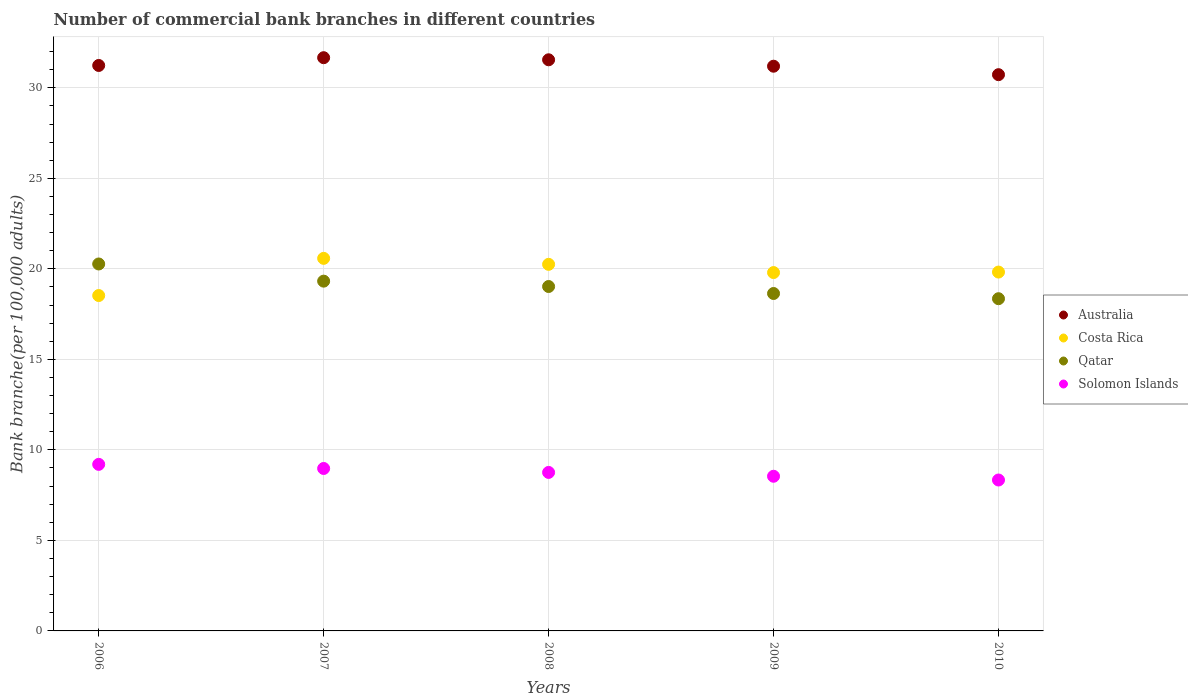Is the number of dotlines equal to the number of legend labels?
Provide a short and direct response. Yes. What is the number of commercial bank branches in Qatar in 2007?
Ensure brevity in your answer.  19.32. Across all years, what is the maximum number of commercial bank branches in Costa Rica?
Give a very brief answer. 20.58. Across all years, what is the minimum number of commercial bank branches in Solomon Islands?
Provide a succinct answer. 8.34. In which year was the number of commercial bank branches in Costa Rica minimum?
Keep it short and to the point. 2006. What is the total number of commercial bank branches in Costa Rica in the graph?
Offer a very short reply. 98.97. What is the difference between the number of commercial bank branches in Solomon Islands in 2006 and that in 2007?
Offer a terse response. 0.23. What is the difference between the number of commercial bank branches in Solomon Islands in 2009 and the number of commercial bank branches in Qatar in 2008?
Give a very brief answer. -10.48. What is the average number of commercial bank branches in Qatar per year?
Give a very brief answer. 19.12. In the year 2008, what is the difference between the number of commercial bank branches in Solomon Islands and number of commercial bank branches in Costa Rica?
Your answer should be compact. -11.49. What is the ratio of the number of commercial bank branches in Costa Rica in 2007 to that in 2009?
Your response must be concise. 1.04. Is the difference between the number of commercial bank branches in Solomon Islands in 2009 and 2010 greater than the difference between the number of commercial bank branches in Costa Rica in 2009 and 2010?
Your response must be concise. Yes. What is the difference between the highest and the second highest number of commercial bank branches in Costa Rica?
Provide a succinct answer. 0.33. What is the difference between the highest and the lowest number of commercial bank branches in Costa Rica?
Offer a terse response. 2.05. Is it the case that in every year, the sum of the number of commercial bank branches in Solomon Islands and number of commercial bank branches in Australia  is greater than the sum of number of commercial bank branches in Costa Rica and number of commercial bank branches in Qatar?
Make the answer very short. No. Is it the case that in every year, the sum of the number of commercial bank branches in Costa Rica and number of commercial bank branches in Qatar  is greater than the number of commercial bank branches in Australia?
Your response must be concise. Yes. Does the number of commercial bank branches in Australia monotonically increase over the years?
Your response must be concise. No. How many years are there in the graph?
Provide a short and direct response. 5. What is the difference between two consecutive major ticks on the Y-axis?
Provide a succinct answer. 5. Are the values on the major ticks of Y-axis written in scientific E-notation?
Your response must be concise. No. How are the legend labels stacked?
Keep it short and to the point. Vertical. What is the title of the graph?
Offer a terse response. Number of commercial bank branches in different countries. What is the label or title of the X-axis?
Your response must be concise. Years. What is the label or title of the Y-axis?
Ensure brevity in your answer.  Bank branche(per 100,0 adults). What is the Bank branche(per 100,000 adults) in Australia in 2006?
Keep it short and to the point. 31.23. What is the Bank branche(per 100,000 adults) in Costa Rica in 2006?
Your response must be concise. 18.53. What is the Bank branche(per 100,000 adults) in Qatar in 2006?
Provide a short and direct response. 20.27. What is the Bank branche(per 100,000 adults) of Solomon Islands in 2006?
Offer a very short reply. 9.2. What is the Bank branche(per 100,000 adults) of Australia in 2007?
Your answer should be compact. 31.66. What is the Bank branche(per 100,000 adults) of Costa Rica in 2007?
Your answer should be very brief. 20.58. What is the Bank branche(per 100,000 adults) of Qatar in 2007?
Provide a succinct answer. 19.32. What is the Bank branche(per 100,000 adults) in Solomon Islands in 2007?
Your response must be concise. 8.97. What is the Bank branche(per 100,000 adults) of Australia in 2008?
Your answer should be very brief. 31.55. What is the Bank branche(per 100,000 adults) in Costa Rica in 2008?
Offer a very short reply. 20.25. What is the Bank branche(per 100,000 adults) in Qatar in 2008?
Offer a terse response. 19.02. What is the Bank branche(per 100,000 adults) in Solomon Islands in 2008?
Provide a succinct answer. 8.75. What is the Bank branche(per 100,000 adults) of Australia in 2009?
Offer a terse response. 31.19. What is the Bank branche(per 100,000 adults) of Costa Rica in 2009?
Provide a short and direct response. 19.79. What is the Bank branche(per 100,000 adults) of Qatar in 2009?
Your answer should be very brief. 18.64. What is the Bank branche(per 100,000 adults) of Solomon Islands in 2009?
Ensure brevity in your answer.  8.54. What is the Bank branche(per 100,000 adults) of Australia in 2010?
Keep it short and to the point. 30.73. What is the Bank branche(per 100,000 adults) in Costa Rica in 2010?
Your response must be concise. 19.82. What is the Bank branche(per 100,000 adults) of Qatar in 2010?
Provide a short and direct response. 18.35. What is the Bank branche(per 100,000 adults) in Solomon Islands in 2010?
Make the answer very short. 8.34. Across all years, what is the maximum Bank branche(per 100,000 adults) of Australia?
Provide a short and direct response. 31.66. Across all years, what is the maximum Bank branche(per 100,000 adults) of Costa Rica?
Give a very brief answer. 20.58. Across all years, what is the maximum Bank branche(per 100,000 adults) of Qatar?
Your response must be concise. 20.27. Across all years, what is the maximum Bank branche(per 100,000 adults) in Solomon Islands?
Your response must be concise. 9.2. Across all years, what is the minimum Bank branche(per 100,000 adults) of Australia?
Your response must be concise. 30.73. Across all years, what is the minimum Bank branche(per 100,000 adults) of Costa Rica?
Provide a short and direct response. 18.53. Across all years, what is the minimum Bank branche(per 100,000 adults) in Qatar?
Your answer should be very brief. 18.35. Across all years, what is the minimum Bank branche(per 100,000 adults) in Solomon Islands?
Provide a short and direct response. 8.34. What is the total Bank branche(per 100,000 adults) of Australia in the graph?
Provide a short and direct response. 156.36. What is the total Bank branche(per 100,000 adults) in Costa Rica in the graph?
Offer a very short reply. 98.97. What is the total Bank branche(per 100,000 adults) in Qatar in the graph?
Provide a short and direct response. 95.6. What is the total Bank branche(per 100,000 adults) of Solomon Islands in the graph?
Your response must be concise. 43.81. What is the difference between the Bank branche(per 100,000 adults) of Australia in 2006 and that in 2007?
Give a very brief answer. -0.43. What is the difference between the Bank branche(per 100,000 adults) of Costa Rica in 2006 and that in 2007?
Give a very brief answer. -2.05. What is the difference between the Bank branche(per 100,000 adults) in Qatar in 2006 and that in 2007?
Your answer should be compact. 0.95. What is the difference between the Bank branche(per 100,000 adults) in Solomon Islands in 2006 and that in 2007?
Your response must be concise. 0.23. What is the difference between the Bank branche(per 100,000 adults) in Australia in 2006 and that in 2008?
Make the answer very short. -0.31. What is the difference between the Bank branche(per 100,000 adults) in Costa Rica in 2006 and that in 2008?
Your answer should be very brief. -1.72. What is the difference between the Bank branche(per 100,000 adults) in Qatar in 2006 and that in 2008?
Provide a short and direct response. 1.25. What is the difference between the Bank branche(per 100,000 adults) of Solomon Islands in 2006 and that in 2008?
Make the answer very short. 0.45. What is the difference between the Bank branche(per 100,000 adults) in Australia in 2006 and that in 2009?
Give a very brief answer. 0.04. What is the difference between the Bank branche(per 100,000 adults) in Costa Rica in 2006 and that in 2009?
Provide a succinct answer. -1.27. What is the difference between the Bank branche(per 100,000 adults) of Qatar in 2006 and that in 2009?
Give a very brief answer. 1.63. What is the difference between the Bank branche(per 100,000 adults) in Solomon Islands in 2006 and that in 2009?
Your answer should be very brief. 0.66. What is the difference between the Bank branche(per 100,000 adults) in Australia in 2006 and that in 2010?
Offer a very short reply. 0.51. What is the difference between the Bank branche(per 100,000 adults) of Costa Rica in 2006 and that in 2010?
Your answer should be compact. -1.3. What is the difference between the Bank branche(per 100,000 adults) of Qatar in 2006 and that in 2010?
Your answer should be compact. 1.92. What is the difference between the Bank branche(per 100,000 adults) of Solomon Islands in 2006 and that in 2010?
Ensure brevity in your answer.  0.86. What is the difference between the Bank branche(per 100,000 adults) in Australia in 2007 and that in 2008?
Keep it short and to the point. 0.12. What is the difference between the Bank branche(per 100,000 adults) in Costa Rica in 2007 and that in 2008?
Provide a short and direct response. 0.33. What is the difference between the Bank branche(per 100,000 adults) of Qatar in 2007 and that in 2008?
Provide a short and direct response. 0.3. What is the difference between the Bank branche(per 100,000 adults) in Solomon Islands in 2007 and that in 2008?
Provide a short and direct response. 0.22. What is the difference between the Bank branche(per 100,000 adults) of Australia in 2007 and that in 2009?
Provide a short and direct response. 0.47. What is the difference between the Bank branche(per 100,000 adults) of Costa Rica in 2007 and that in 2009?
Give a very brief answer. 0.78. What is the difference between the Bank branche(per 100,000 adults) in Qatar in 2007 and that in 2009?
Your answer should be very brief. 0.68. What is the difference between the Bank branche(per 100,000 adults) in Solomon Islands in 2007 and that in 2009?
Ensure brevity in your answer.  0.43. What is the difference between the Bank branche(per 100,000 adults) of Australia in 2007 and that in 2010?
Offer a very short reply. 0.94. What is the difference between the Bank branche(per 100,000 adults) of Costa Rica in 2007 and that in 2010?
Offer a terse response. 0.76. What is the difference between the Bank branche(per 100,000 adults) in Qatar in 2007 and that in 2010?
Your answer should be very brief. 0.97. What is the difference between the Bank branche(per 100,000 adults) of Solomon Islands in 2007 and that in 2010?
Your answer should be very brief. 0.64. What is the difference between the Bank branche(per 100,000 adults) in Australia in 2008 and that in 2009?
Give a very brief answer. 0.35. What is the difference between the Bank branche(per 100,000 adults) of Costa Rica in 2008 and that in 2009?
Keep it short and to the point. 0.45. What is the difference between the Bank branche(per 100,000 adults) in Qatar in 2008 and that in 2009?
Your answer should be very brief. 0.39. What is the difference between the Bank branche(per 100,000 adults) in Solomon Islands in 2008 and that in 2009?
Give a very brief answer. 0.21. What is the difference between the Bank branche(per 100,000 adults) of Australia in 2008 and that in 2010?
Your answer should be very brief. 0.82. What is the difference between the Bank branche(per 100,000 adults) in Costa Rica in 2008 and that in 2010?
Your response must be concise. 0.43. What is the difference between the Bank branche(per 100,000 adults) in Qatar in 2008 and that in 2010?
Provide a short and direct response. 0.67. What is the difference between the Bank branche(per 100,000 adults) in Solomon Islands in 2008 and that in 2010?
Keep it short and to the point. 0.42. What is the difference between the Bank branche(per 100,000 adults) of Australia in 2009 and that in 2010?
Offer a terse response. 0.47. What is the difference between the Bank branche(per 100,000 adults) in Costa Rica in 2009 and that in 2010?
Provide a succinct answer. -0.03. What is the difference between the Bank branche(per 100,000 adults) in Qatar in 2009 and that in 2010?
Your answer should be compact. 0.29. What is the difference between the Bank branche(per 100,000 adults) in Solomon Islands in 2009 and that in 2010?
Provide a succinct answer. 0.21. What is the difference between the Bank branche(per 100,000 adults) of Australia in 2006 and the Bank branche(per 100,000 adults) of Costa Rica in 2007?
Provide a short and direct response. 10.65. What is the difference between the Bank branche(per 100,000 adults) in Australia in 2006 and the Bank branche(per 100,000 adults) in Qatar in 2007?
Give a very brief answer. 11.91. What is the difference between the Bank branche(per 100,000 adults) in Australia in 2006 and the Bank branche(per 100,000 adults) in Solomon Islands in 2007?
Offer a terse response. 22.26. What is the difference between the Bank branche(per 100,000 adults) in Costa Rica in 2006 and the Bank branche(per 100,000 adults) in Qatar in 2007?
Make the answer very short. -0.79. What is the difference between the Bank branche(per 100,000 adults) in Costa Rica in 2006 and the Bank branche(per 100,000 adults) in Solomon Islands in 2007?
Provide a short and direct response. 9.55. What is the difference between the Bank branche(per 100,000 adults) of Qatar in 2006 and the Bank branche(per 100,000 adults) of Solomon Islands in 2007?
Make the answer very short. 11.3. What is the difference between the Bank branche(per 100,000 adults) of Australia in 2006 and the Bank branche(per 100,000 adults) of Costa Rica in 2008?
Provide a succinct answer. 10.99. What is the difference between the Bank branche(per 100,000 adults) in Australia in 2006 and the Bank branche(per 100,000 adults) in Qatar in 2008?
Ensure brevity in your answer.  12.21. What is the difference between the Bank branche(per 100,000 adults) of Australia in 2006 and the Bank branche(per 100,000 adults) of Solomon Islands in 2008?
Provide a succinct answer. 22.48. What is the difference between the Bank branche(per 100,000 adults) of Costa Rica in 2006 and the Bank branche(per 100,000 adults) of Qatar in 2008?
Your response must be concise. -0.5. What is the difference between the Bank branche(per 100,000 adults) of Costa Rica in 2006 and the Bank branche(per 100,000 adults) of Solomon Islands in 2008?
Keep it short and to the point. 9.77. What is the difference between the Bank branche(per 100,000 adults) in Qatar in 2006 and the Bank branche(per 100,000 adults) in Solomon Islands in 2008?
Your response must be concise. 11.51. What is the difference between the Bank branche(per 100,000 adults) in Australia in 2006 and the Bank branche(per 100,000 adults) in Costa Rica in 2009?
Provide a succinct answer. 11.44. What is the difference between the Bank branche(per 100,000 adults) in Australia in 2006 and the Bank branche(per 100,000 adults) in Qatar in 2009?
Your answer should be very brief. 12.6. What is the difference between the Bank branche(per 100,000 adults) in Australia in 2006 and the Bank branche(per 100,000 adults) in Solomon Islands in 2009?
Provide a short and direct response. 22.69. What is the difference between the Bank branche(per 100,000 adults) of Costa Rica in 2006 and the Bank branche(per 100,000 adults) of Qatar in 2009?
Your response must be concise. -0.11. What is the difference between the Bank branche(per 100,000 adults) of Costa Rica in 2006 and the Bank branche(per 100,000 adults) of Solomon Islands in 2009?
Ensure brevity in your answer.  9.98. What is the difference between the Bank branche(per 100,000 adults) of Qatar in 2006 and the Bank branche(per 100,000 adults) of Solomon Islands in 2009?
Provide a short and direct response. 11.73. What is the difference between the Bank branche(per 100,000 adults) of Australia in 2006 and the Bank branche(per 100,000 adults) of Costa Rica in 2010?
Provide a succinct answer. 11.41. What is the difference between the Bank branche(per 100,000 adults) in Australia in 2006 and the Bank branche(per 100,000 adults) in Qatar in 2010?
Provide a short and direct response. 12.88. What is the difference between the Bank branche(per 100,000 adults) in Australia in 2006 and the Bank branche(per 100,000 adults) in Solomon Islands in 2010?
Your answer should be very brief. 22.9. What is the difference between the Bank branche(per 100,000 adults) of Costa Rica in 2006 and the Bank branche(per 100,000 adults) of Qatar in 2010?
Your response must be concise. 0.18. What is the difference between the Bank branche(per 100,000 adults) of Costa Rica in 2006 and the Bank branche(per 100,000 adults) of Solomon Islands in 2010?
Ensure brevity in your answer.  10.19. What is the difference between the Bank branche(per 100,000 adults) of Qatar in 2006 and the Bank branche(per 100,000 adults) of Solomon Islands in 2010?
Your response must be concise. 11.93. What is the difference between the Bank branche(per 100,000 adults) of Australia in 2007 and the Bank branche(per 100,000 adults) of Costa Rica in 2008?
Offer a terse response. 11.41. What is the difference between the Bank branche(per 100,000 adults) of Australia in 2007 and the Bank branche(per 100,000 adults) of Qatar in 2008?
Ensure brevity in your answer.  12.64. What is the difference between the Bank branche(per 100,000 adults) of Australia in 2007 and the Bank branche(per 100,000 adults) of Solomon Islands in 2008?
Your answer should be compact. 22.91. What is the difference between the Bank branche(per 100,000 adults) in Costa Rica in 2007 and the Bank branche(per 100,000 adults) in Qatar in 2008?
Keep it short and to the point. 1.56. What is the difference between the Bank branche(per 100,000 adults) in Costa Rica in 2007 and the Bank branche(per 100,000 adults) in Solomon Islands in 2008?
Your answer should be compact. 11.82. What is the difference between the Bank branche(per 100,000 adults) in Qatar in 2007 and the Bank branche(per 100,000 adults) in Solomon Islands in 2008?
Your response must be concise. 10.57. What is the difference between the Bank branche(per 100,000 adults) in Australia in 2007 and the Bank branche(per 100,000 adults) in Costa Rica in 2009?
Keep it short and to the point. 11.87. What is the difference between the Bank branche(per 100,000 adults) of Australia in 2007 and the Bank branche(per 100,000 adults) of Qatar in 2009?
Offer a very short reply. 13.03. What is the difference between the Bank branche(per 100,000 adults) of Australia in 2007 and the Bank branche(per 100,000 adults) of Solomon Islands in 2009?
Ensure brevity in your answer.  23.12. What is the difference between the Bank branche(per 100,000 adults) of Costa Rica in 2007 and the Bank branche(per 100,000 adults) of Qatar in 2009?
Give a very brief answer. 1.94. What is the difference between the Bank branche(per 100,000 adults) of Costa Rica in 2007 and the Bank branche(per 100,000 adults) of Solomon Islands in 2009?
Provide a short and direct response. 12.04. What is the difference between the Bank branche(per 100,000 adults) of Qatar in 2007 and the Bank branche(per 100,000 adults) of Solomon Islands in 2009?
Keep it short and to the point. 10.78. What is the difference between the Bank branche(per 100,000 adults) of Australia in 2007 and the Bank branche(per 100,000 adults) of Costa Rica in 2010?
Provide a succinct answer. 11.84. What is the difference between the Bank branche(per 100,000 adults) of Australia in 2007 and the Bank branche(per 100,000 adults) of Qatar in 2010?
Make the answer very short. 13.31. What is the difference between the Bank branche(per 100,000 adults) of Australia in 2007 and the Bank branche(per 100,000 adults) of Solomon Islands in 2010?
Make the answer very short. 23.33. What is the difference between the Bank branche(per 100,000 adults) in Costa Rica in 2007 and the Bank branche(per 100,000 adults) in Qatar in 2010?
Provide a succinct answer. 2.23. What is the difference between the Bank branche(per 100,000 adults) of Costa Rica in 2007 and the Bank branche(per 100,000 adults) of Solomon Islands in 2010?
Offer a terse response. 12.24. What is the difference between the Bank branche(per 100,000 adults) of Qatar in 2007 and the Bank branche(per 100,000 adults) of Solomon Islands in 2010?
Offer a very short reply. 10.98. What is the difference between the Bank branche(per 100,000 adults) in Australia in 2008 and the Bank branche(per 100,000 adults) in Costa Rica in 2009?
Offer a very short reply. 11.75. What is the difference between the Bank branche(per 100,000 adults) in Australia in 2008 and the Bank branche(per 100,000 adults) in Qatar in 2009?
Give a very brief answer. 12.91. What is the difference between the Bank branche(per 100,000 adults) in Australia in 2008 and the Bank branche(per 100,000 adults) in Solomon Islands in 2009?
Provide a short and direct response. 23. What is the difference between the Bank branche(per 100,000 adults) in Costa Rica in 2008 and the Bank branche(per 100,000 adults) in Qatar in 2009?
Your answer should be compact. 1.61. What is the difference between the Bank branche(per 100,000 adults) in Costa Rica in 2008 and the Bank branche(per 100,000 adults) in Solomon Islands in 2009?
Provide a succinct answer. 11.71. What is the difference between the Bank branche(per 100,000 adults) of Qatar in 2008 and the Bank branche(per 100,000 adults) of Solomon Islands in 2009?
Keep it short and to the point. 10.48. What is the difference between the Bank branche(per 100,000 adults) in Australia in 2008 and the Bank branche(per 100,000 adults) in Costa Rica in 2010?
Your response must be concise. 11.73. What is the difference between the Bank branche(per 100,000 adults) in Australia in 2008 and the Bank branche(per 100,000 adults) in Qatar in 2010?
Ensure brevity in your answer.  13.2. What is the difference between the Bank branche(per 100,000 adults) in Australia in 2008 and the Bank branche(per 100,000 adults) in Solomon Islands in 2010?
Give a very brief answer. 23.21. What is the difference between the Bank branche(per 100,000 adults) in Costa Rica in 2008 and the Bank branche(per 100,000 adults) in Qatar in 2010?
Ensure brevity in your answer.  1.9. What is the difference between the Bank branche(per 100,000 adults) of Costa Rica in 2008 and the Bank branche(per 100,000 adults) of Solomon Islands in 2010?
Offer a very short reply. 11.91. What is the difference between the Bank branche(per 100,000 adults) in Qatar in 2008 and the Bank branche(per 100,000 adults) in Solomon Islands in 2010?
Provide a succinct answer. 10.69. What is the difference between the Bank branche(per 100,000 adults) in Australia in 2009 and the Bank branche(per 100,000 adults) in Costa Rica in 2010?
Offer a very short reply. 11.37. What is the difference between the Bank branche(per 100,000 adults) in Australia in 2009 and the Bank branche(per 100,000 adults) in Qatar in 2010?
Keep it short and to the point. 12.84. What is the difference between the Bank branche(per 100,000 adults) in Australia in 2009 and the Bank branche(per 100,000 adults) in Solomon Islands in 2010?
Your response must be concise. 22.86. What is the difference between the Bank branche(per 100,000 adults) in Costa Rica in 2009 and the Bank branche(per 100,000 adults) in Qatar in 2010?
Offer a very short reply. 1.44. What is the difference between the Bank branche(per 100,000 adults) of Costa Rica in 2009 and the Bank branche(per 100,000 adults) of Solomon Islands in 2010?
Provide a succinct answer. 11.46. What is the difference between the Bank branche(per 100,000 adults) of Qatar in 2009 and the Bank branche(per 100,000 adults) of Solomon Islands in 2010?
Your answer should be compact. 10.3. What is the average Bank branche(per 100,000 adults) of Australia per year?
Offer a terse response. 31.27. What is the average Bank branche(per 100,000 adults) of Costa Rica per year?
Offer a terse response. 19.79. What is the average Bank branche(per 100,000 adults) in Qatar per year?
Keep it short and to the point. 19.12. What is the average Bank branche(per 100,000 adults) of Solomon Islands per year?
Provide a succinct answer. 8.76. In the year 2006, what is the difference between the Bank branche(per 100,000 adults) of Australia and Bank branche(per 100,000 adults) of Costa Rica?
Ensure brevity in your answer.  12.71. In the year 2006, what is the difference between the Bank branche(per 100,000 adults) of Australia and Bank branche(per 100,000 adults) of Qatar?
Provide a succinct answer. 10.96. In the year 2006, what is the difference between the Bank branche(per 100,000 adults) of Australia and Bank branche(per 100,000 adults) of Solomon Islands?
Offer a very short reply. 22.03. In the year 2006, what is the difference between the Bank branche(per 100,000 adults) of Costa Rica and Bank branche(per 100,000 adults) of Qatar?
Your answer should be compact. -1.74. In the year 2006, what is the difference between the Bank branche(per 100,000 adults) in Costa Rica and Bank branche(per 100,000 adults) in Solomon Islands?
Your answer should be compact. 9.33. In the year 2006, what is the difference between the Bank branche(per 100,000 adults) in Qatar and Bank branche(per 100,000 adults) in Solomon Islands?
Give a very brief answer. 11.07. In the year 2007, what is the difference between the Bank branche(per 100,000 adults) of Australia and Bank branche(per 100,000 adults) of Costa Rica?
Your answer should be compact. 11.08. In the year 2007, what is the difference between the Bank branche(per 100,000 adults) of Australia and Bank branche(per 100,000 adults) of Qatar?
Provide a short and direct response. 12.34. In the year 2007, what is the difference between the Bank branche(per 100,000 adults) of Australia and Bank branche(per 100,000 adults) of Solomon Islands?
Keep it short and to the point. 22.69. In the year 2007, what is the difference between the Bank branche(per 100,000 adults) in Costa Rica and Bank branche(per 100,000 adults) in Qatar?
Give a very brief answer. 1.26. In the year 2007, what is the difference between the Bank branche(per 100,000 adults) in Costa Rica and Bank branche(per 100,000 adults) in Solomon Islands?
Provide a succinct answer. 11.61. In the year 2007, what is the difference between the Bank branche(per 100,000 adults) of Qatar and Bank branche(per 100,000 adults) of Solomon Islands?
Give a very brief answer. 10.35. In the year 2008, what is the difference between the Bank branche(per 100,000 adults) of Australia and Bank branche(per 100,000 adults) of Costa Rica?
Your answer should be very brief. 11.3. In the year 2008, what is the difference between the Bank branche(per 100,000 adults) in Australia and Bank branche(per 100,000 adults) in Qatar?
Your answer should be very brief. 12.52. In the year 2008, what is the difference between the Bank branche(per 100,000 adults) in Australia and Bank branche(per 100,000 adults) in Solomon Islands?
Give a very brief answer. 22.79. In the year 2008, what is the difference between the Bank branche(per 100,000 adults) of Costa Rica and Bank branche(per 100,000 adults) of Qatar?
Provide a succinct answer. 1.22. In the year 2008, what is the difference between the Bank branche(per 100,000 adults) of Costa Rica and Bank branche(per 100,000 adults) of Solomon Islands?
Ensure brevity in your answer.  11.49. In the year 2008, what is the difference between the Bank branche(per 100,000 adults) of Qatar and Bank branche(per 100,000 adults) of Solomon Islands?
Give a very brief answer. 10.27. In the year 2009, what is the difference between the Bank branche(per 100,000 adults) of Australia and Bank branche(per 100,000 adults) of Costa Rica?
Your answer should be compact. 11.4. In the year 2009, what is the difference between the Bank branche(per 100,000 adults) of Australia and Bank branche(per 100,000 adults) of Qatar?
Provide a short and direct response. 12.55. In the year 2009, what is the difference between the Bank branche(per 100,000 adults) of Australia and Bank branche(per 100,000 adults) of Solomon Islands?
Ensure brevity in your answer.  22.65. In the year 2009, what is the difference between the Bank branche(per 100,000 adults) of Costa Rica and Bank branche(per 100,000 adults) of Qatar?
Provide a succinct answer. 1.16. In the year 2009, what is the difference between the Bank branche(per 100,000 adults) of Costa Rica and Bank branche(per 100,000 adults) of Solomon Islands?
Ensure brevity in your answer.  11.25. In the year 2009, what is the difference between the Bank branche(per 100,000 adults) in Qatar and Bank branche(per 100,000 adults) in Solomon Islands?
Give a very brief answer. 10.1. In the year 2010, what is the difference between the Bank branche(per 100,000 adults) of Australia and Bank branche(per 100,000 adults) of Costa Rica?
Offer a very short reply. 10.9. In the year 2010, what is the difference between the Bank branche(per 100,000 adults) of Australia and Bank branche(per 100,000 adults) of Qatar?
Ensure brevity in your answer.  12.37. In the year 2010, what is the difference between the Bank branche(per 100,000 adults) in Australia and Bank branche(per 100,000 adults) in Solomon Islands?
Ensure brevity in your answer.  22.39. In the year 2010, what is the difference between the Bank branche(per 100,000 adults) of Costa Rica and Bank branche(per 100,000 adults) of Qatar?
Your answer should be compact. 1.47. In the year 2010, what is the difference between the Bank branche(per 100,000 adults) in Costa Rica and Bank branche(per 100,000 adults) in Solomon Islands?
Offer a terse response. 11.49. In the year 2010, what is the difference between the Bank branche(per 100,000 adults) of Qatar and Bank branche(per 100,000 adults) of Solomon Islands?
Keep it short and to the point. 10.01. What is the ratio of the Bank branche(per 100,000 adults) in Australia in 2006 to that in 2007?
Offer a very short reply. 0.99. What is the ratio of the Bank branche(per 100,000 adults) of Costa Rica in 2006 to that in 2007?
Keep it short and to the point. 0.9. What is the ratio of the Bank branche(per 100,000 adults) of Qatar in 2006 to that in 2007?
Offer a very short reply. 1.05. What is the ratio of the Bank branche(per 100,000 adults) of Solomon Islands in 2006 to that in 2007?
Your answer should be compact. 1.03. What is the ratio of the Bank branche(per 100,000 adults) of Costa Rica in 2006 to that in 2008?
Offer a very short reply. 0.91. What is the ratio of the Bank branche(per 100,000 adults) of Qatar in 2006 to that in 2008?
Ensure brevity in your answer.  1.07. What is the ratio of the Bank branche(per 100,000 adults) in Solomon Islands in 2006 to that in 2008?
Your response must be concise. 1.05. What is the ratio of the Bank branche(per 100,000 adults) in Australia in 2006 to that in 2009?
Give a very brief answer. 1. What is the ratio of the Bank branche(per 100,000 adults) of Costa Rica in 2006 to that in 2009?
Your response must be concise. 0.94. What is the ratio of the Bank branche(per 100,000 adults) in Qatar in 2006 to that in 2009?
Give a very brief answer. 1.09. What is the ratio of the Bank branche(per 100,000 adults) of Australia in 2006 to that in 2010?
Your answer should be very brief. 1.02. What is the ratio of the Bank branche(per 100,000 adults) in Costa Rica in 2006 to that in 2010?
Your answer should be very brief. 0.93. What is the ratio of the Bank branche(per 100,000 adults) of Qatar in 2006 to that in 2010?
Your response must be concise. 1.1. What is the ratio of the Bank branche(per 100,000 adults) of Solomon Islands in 2006 to that in 2010?
Your answer should be compact. 1.1. What is the ratio of the Bank branche(per 100,000 adults) of Australia in 2007 to that in 2008?
Ensure brevity in your answer.  1. What is the ratio of the Bank branche(per 100,000 adults) of Costa Rica in 2007 to that in 2008?
Give a very brief answer. 1.02. What is the ratio of the Bank branche(per 100,000 adults) in Qatar in 2007 to that in 2008?
Provide a succinct answer. 1.02. What is the ratio of the Bank branche(per 100,000 adults) in Solomon Islands in 2007 to that in 2008?
Give a very brief answer. 1.02. What is the ratio of the Bank branche(per 100,000 adults) in Australia in 2007 to that in 2009?
Offer a very short reply. 1.02. What is the ratio of the Bank branche(per 100,000 adults) of Costa Rica in 2007 to that in 2009?
Your response must be concise. 1.04. What is the ratio of the Bank branche(per 100,000 adults) of Qatar in 2007 to that in 2009?
Keep it short and to the point. 1.04. What is the ratio of the Bank branche(per 100,000 adults) in Solomon Islands in 2007 to that in 2009?
Your answer should be compact. 1.05. What is the ratio of the Bank branche(per 100,000 adults) in Australia in 2007 to that in 2010?
Your answer should be very brief. 1.03. What is the ratio of the Bank branche(per 100,000 adults) in Costa Rica in 2007 to that in 2010?
Your answer should be compact. 1.04. What is the ratio of the Bank branche(per 100,000 adults) in Qatar in 2007 to that in 2010?
Provide a short and direct response. 1.05. What is the ratio of the Bank branche(per 100,000 adults) in Solomon Islands in 2007 to that in 2010?
Offer a very short reply. 1.08. What is the ratio of the Bank branche(per 100,000 adults) in Australia in 2008 to that in 2009?
Provide a succinct answer. 1.01. What is the ratio of the Bank branche(per 100,000 adults) in Qatar in 2008 to that in 2009?
Your answer should be compact. 1.02. What is the ratio of the Bank branche(per 100,000 adults) in Solomon Islands in 2008 to that in 2009?
Ensure brevity in your answer.  1.02. What is the ratio of the Bank branche(per 100,000 adults) in Australia in 2008 to that in 2010?
Make the answer very short. 1.03. What is the ratio of the Bank branche(per 100,000 adults) in Costa Rica in 2008 to that in 2010?
Give a very brief answer. 1.02. What is the ratio of the Bank branche(per 100,000 adults) in Qatar in 2008 to that in 2010?
Offer a terse response. 1.04. What is the ratio of the Bank branche(per 100,000 adults) in Solomon Islands in 2008 to that in 2010?
Your answer should be very brief. 1.05. What is the ratio of the Bank branche(per 100,000 adults) of Australia in 2009 to that in 2010?
Offer a terse response. 1.02. What is the ratio of the Bank branche(per 100,000 adults) of Qatar in 2009 to that in 2010?
Give a very brief answer. 1.02. What is the ratio of the Bank branche(per 100,000 adults) of Solomon Islands in 2009 to that in 2010?
Your answer should be very brief. 1.02. What is the difference between the highest and the second highest Bank branche(per 100,000 adults) in Australia?
Make the answer very short. 0.12. What is the difference between the highest and the second highest Bank branche(per 100,000 adults) of Costa Rica?
Offer a very short reply. 0.33. What is the difference between the highest and the second highest Bank branche(per 100,000 adults) in Qatar?
Ensure brevity in your answer.  0.95. What is the difference between the highest and the second highest Bank branche(per 100,000 adults) of Solomon Islands?
Your answer should be very brief. 0.23. What is the difference between the highest and the lowest Bank branche(per 100,000 adults) in Australia?
Offer a terse response. 0.94. What is the difference between the highest and the lowest Bank branche(per 100,000 adults) in Costa Rica?
Offer a very short reply. 2.05. What is the difference between the highest and the lowest Bank branche(per 100,000 adults) in Qatar?
Your answer should be very brief. 1.92. What is the difference between the highest and the lowest Bank branche(per 100,000 adults) in Solomon Islands?
Ensure brevity in your answer.  0.86. 